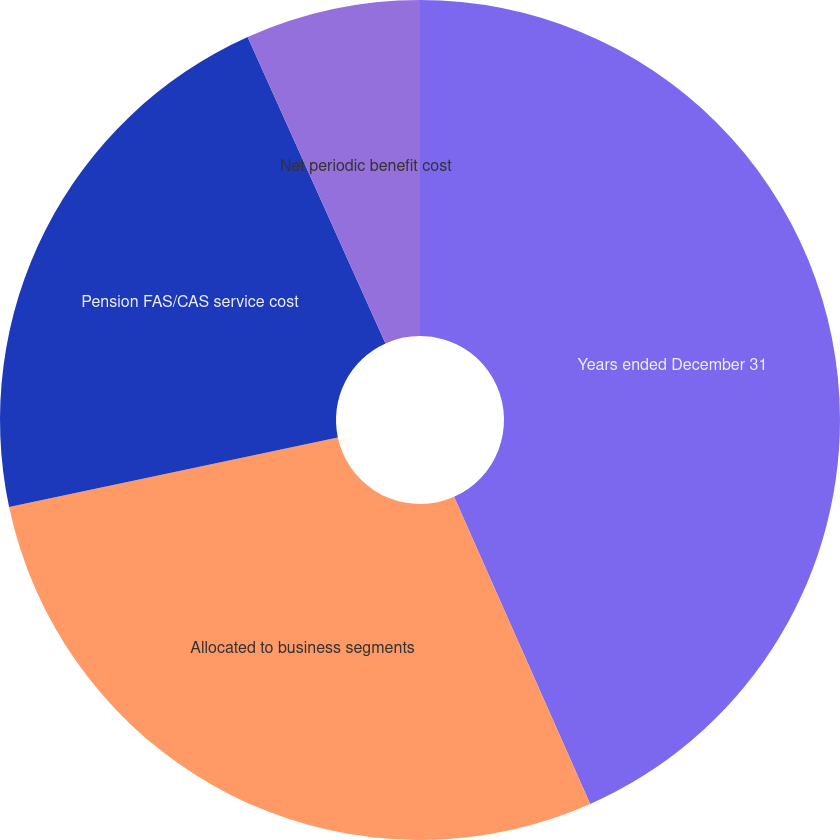<chart> <loc_0><loc_0><loc_500><loc_500><pie_chart><fcel>Years ended December 31<fcel>Allocated to business segments<fcel>Pension FAS/CAS service cost<fcel>Net periodic benefit cost<nl><fcel>43.36%<fcel>28.32%<fcel>21.59%<fcel>6.73%<nl></chart> 